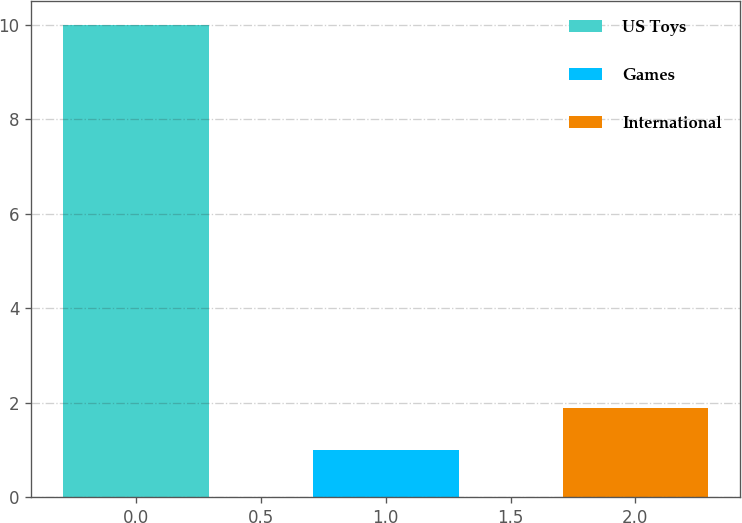Convert chart to OTSL. <chart><loc_0><loc_0><loc_500><loc_500><bar_chart><fcel>US Toys<fcel>Games<fcel>International<nl><fcel>10<fcel>1<fcel>1.9<nl></chart> 